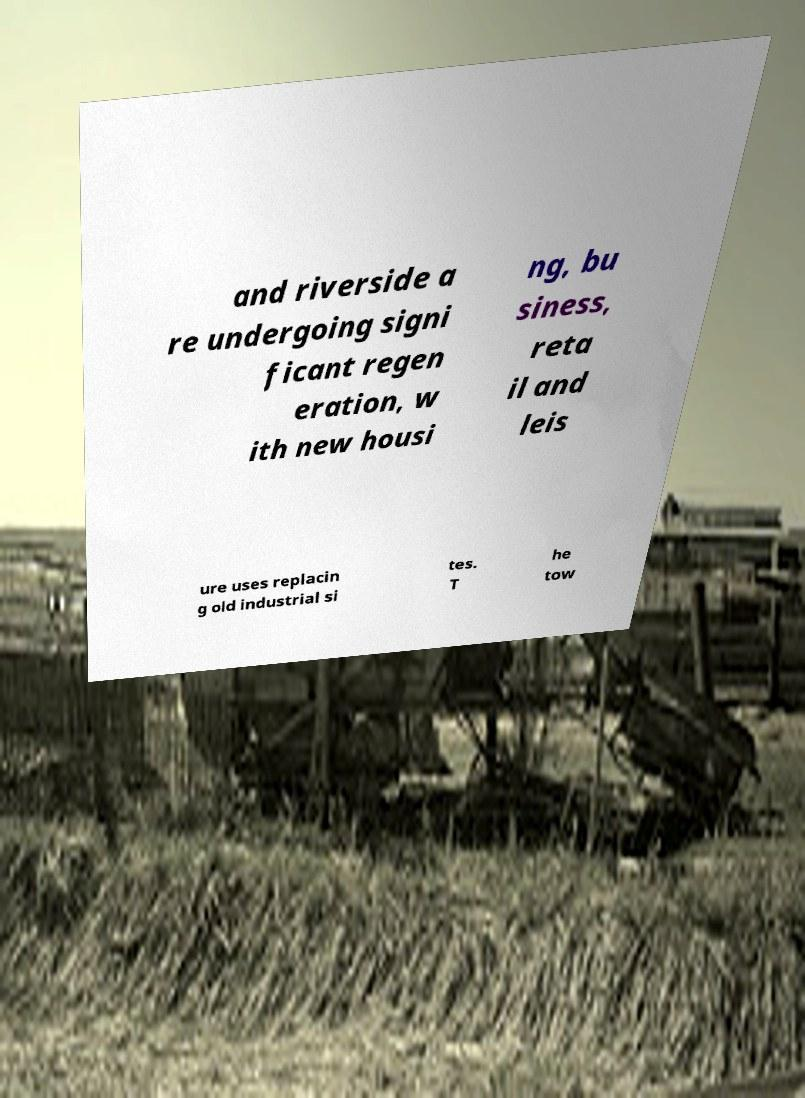There's text embedded in this image that I need extracted. Can you transcribe it verbatim? and riverside a re undergoing signi ficant regen eration, w ith new housi ng, bu siness, reta il and leis ure uses replacin g old industrial si tes. T he tow 